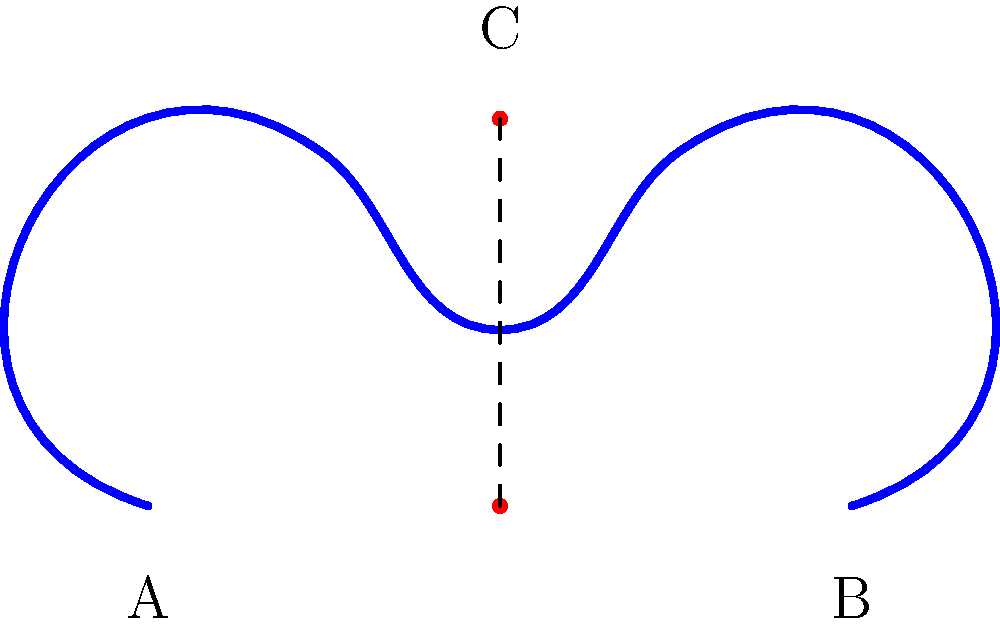Consider the tiara design shown in the figure. The tiara is symmetric about the vertical line through its center. If we define a continuous deformation that preserves this symmetry, which of the following topological properties would remain invariant?

a) The number of peaks
b) The height of the central peak
c) The distance between points A and B
d) The genus of the tiara (number of holes)

Select all that apply. Let's analyze each option step-by-step:

1. Number of peaks:
   - The number of peaks is a topological invariant under continuous deformations.
   - Even if we stretch or compress the tiara, as long as we maintain symmetry, the number of peaks will remain constant.
   - Therefore, this property is invariant.

2. Height of the central peak:
   - The height of the central peak can change under continuous deformations.
   - We can stretch or compress the tiara vertically while maintaining symmetry, which would alter the height of the central peak.
   - This property is not topologically invariant.

3. Distance between points A and B:
   - The distance between points A and B can change under continuous deformations.
   - We can stretch or compress the tiara horizontally while maintaining symmetry, which would alter this distance.
   - This property is not topologically invariant.

4. Genus of the tiara:
   - The genus (number of holes) is a fundamental topological invariant.
   - Continuous deformations cannot create or eliminate holes without breaking the surface.
   - The tiara has a genus of 0 (no holes), and this will remain constant under any continuous deformation.
   - Therefore, this property is invariant.

In topology, properties that remain unchanged under continuous deformations are called topological invariants. The number of peaks and the genus are topological features that are preserved under such transformations, while specific measurements like heights and distances can change.
Answer: a and d 